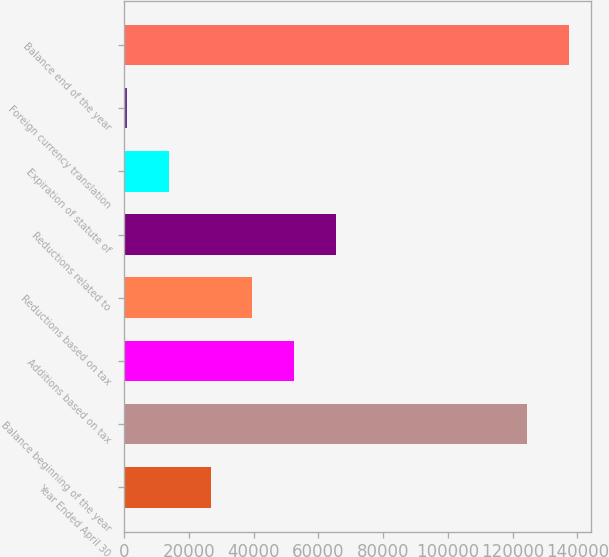<chart> <loc_0><loc_0><loc_500><loc_500><bar_chart><fcel>Year Ended April 30<fcel>Balance beginning of the year<fcel>Additions based on tax<fcel>Reductions based on tax<fcel>Reductions related to<fcel>Expiration of statute of<fcel>Foreign currency translation<fcel>Balance end of the year<nl><fcel>26692.6<fcel>124605<fcel>52461.2<fcel>39576.9<fcel>65345.5<fcel>13808.3<fcel>924<fcel>137489<nl></chart> 